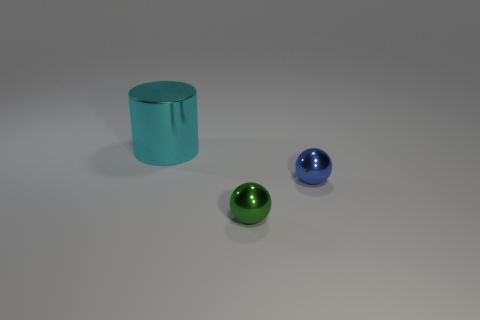Add 2 blue metal things. How many objects exist? 5 Subtract 0 yellow cubes. How many objects are left? 3 Subtract all cylinders. How many objects are left? 2 Subtract all big green objects. Subtract all blue shiny things. How many objects are left? 2 Add 3 big cyan things. How many big cyan things are left? 4 Add 2 small brown matte cubes. How many small brown matte cubes exist? 2 